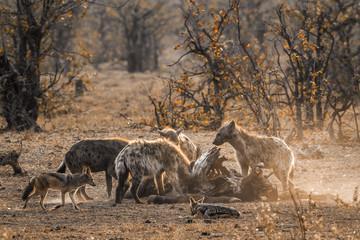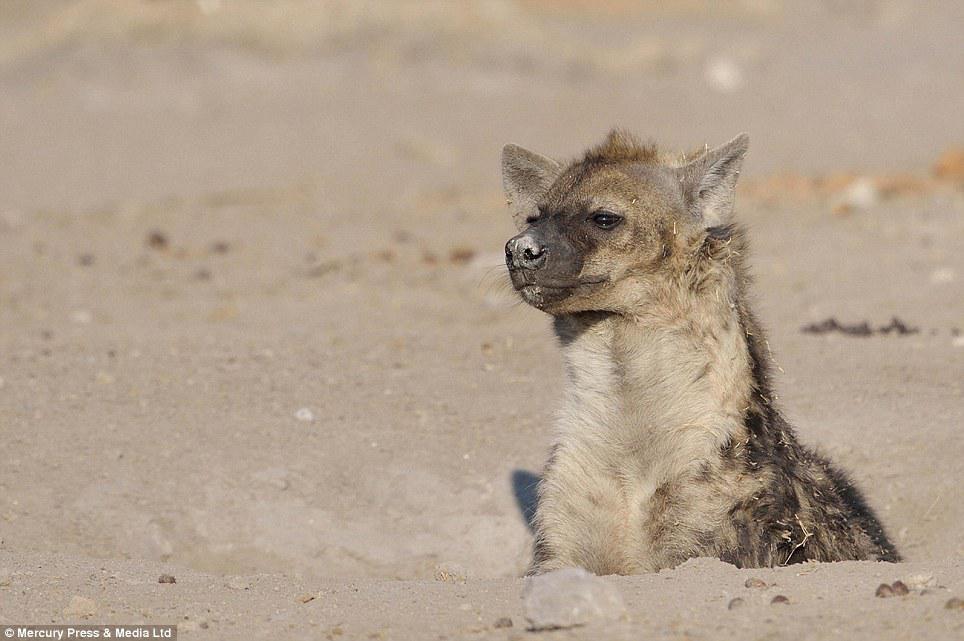The first image is the image on the left, the second image is the image on the right. For the images displayed, is the sentence "At least two prairie dogs are looking straight ahead." factually correct? Answer yes or no. No. The first image is the image on the left, the second image is the image on the right. Analyze the images presented: Is the assertion "The right image has an animal looking to the left." valid? Answer yes or no. Yes. 